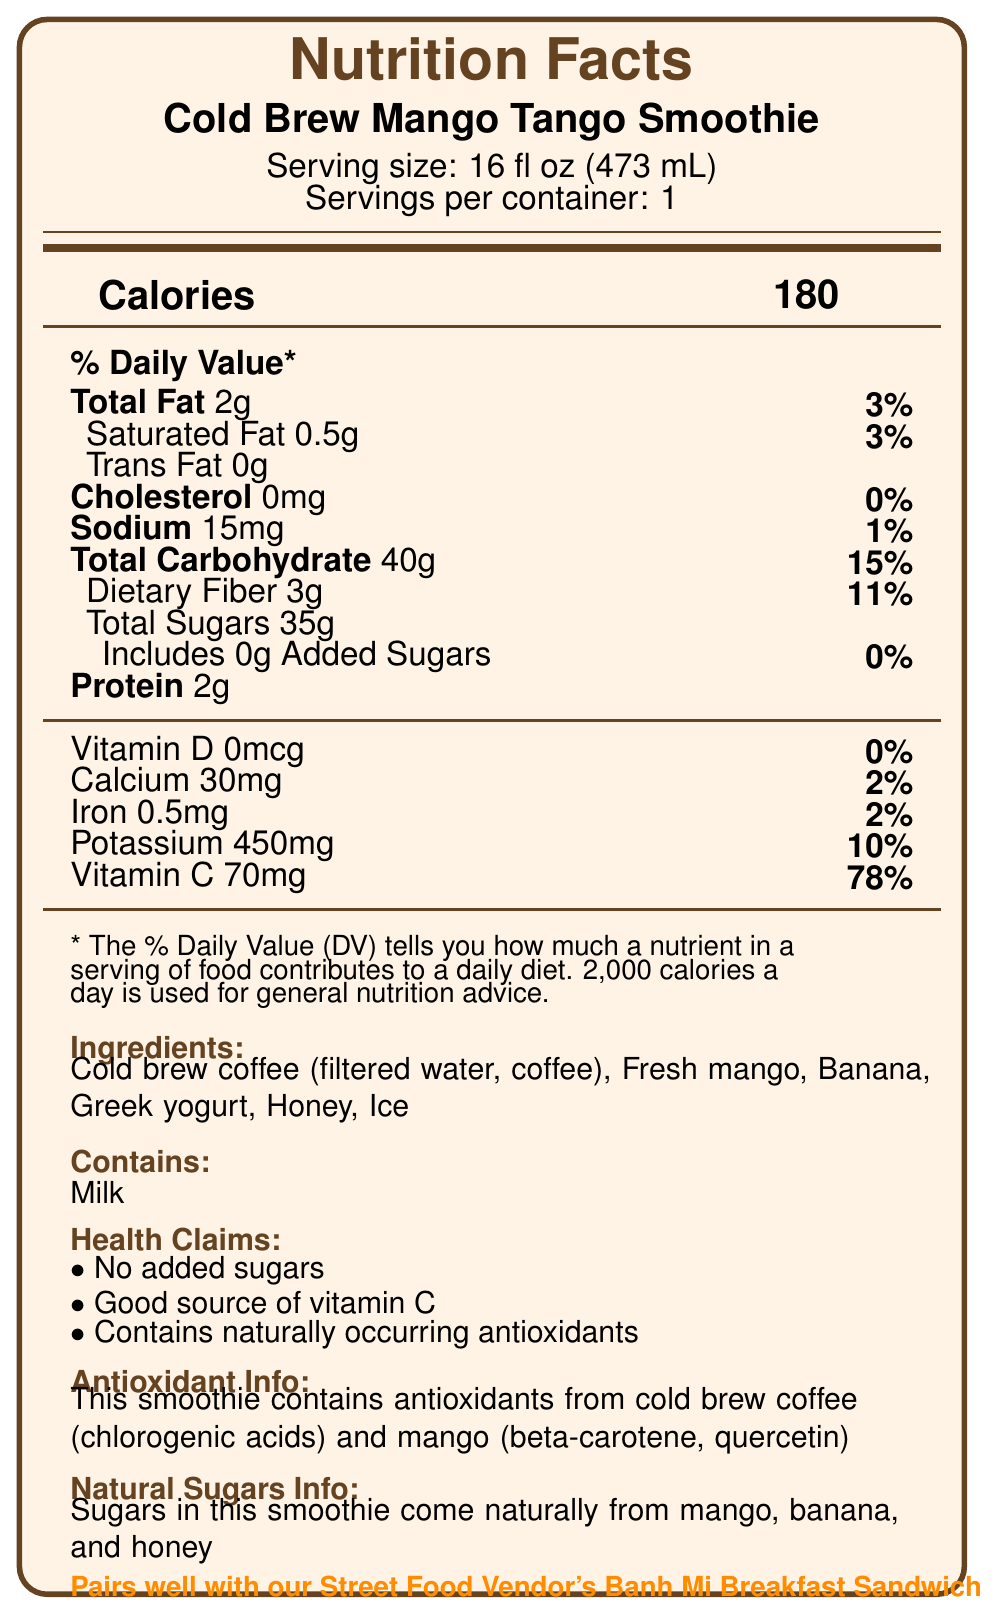what is the serving size of the Cold Brew Mango Tango Smoothie? The serving size is explicitly stated under the product name on the label.
Answer: 16 fl oz (473 mL) how many calories are in one serving of the Cold Brew Mango Tango Smoothie? The number of calories is prominently displayed in the middle of the Nutrition Facts section.
Answer: 180 calories what feature makes this product a good source of vitamin C? The vitamin C content and its percentage of the Daily Value are listed in the Nutrition Facts.
Answer: Contains 70mg of vitamin C per serving, 78% of the Daily Value what are the main sources of sugars in the Cold Brew Mango Tango Smoothie? The Natural Sugars Info section states that sugars come naturally from these ingredients.
Answer: Mango, banana, and honey how much protein does one serving provide? The amount of protein is listed in the Nutrition Facts under the "Protein" section.
Answer: 2g which of the following nutrients is NOT present in the Cold Brew Mango Tango Smoothie? A. Vitamin C B. Calcium C. Vitamin D Vitamin D is listed as 0mcg, which is 0% of the Daily Value.
Answer: C. Vitamin D what is the daily value percentage of dietary fiber in one serving? A. 5% B. 11% C. 15% D. 20% The percentage daily value of dietary fiber is listed as 11% in the Nutrition Facts.
Answer: B. 11% does the Cold Brew Mango Tango Smoothie contain any trans fats? The Nutrition Facts label specifies "Trans Fat 0g".
Answer: No does this product contain any added sugars? The Nutrition Facts state "Includes 0g Added Sugars" which means there are no added sugars.
Answer: No summarize the main features of the Cold Brew Mango Tango Smoothie based on the Nutrition Facts label. This summary includes details about serving size, calorie content, macronutrients, key vitamins, ingredients, pairing suggestions, and allergens.
Answer: The Cold Brew Mango Tango Smoothie is a 16 fl oz drink with 180 calories per serving. It contains 2g of total fat, 40g of carbohydrates, 35g of total sugars with no added sugars, and 2g of protein. It is rich in vitamin C, providing 78% of the daily value, and contains naturally occurring antioxidants from cold brew coffee and mango. It is recommended to pair with a Banh Mi Breakfast Sandwich. The ingredients include cold brew coffee, mango, banana, Greek yogurt, honey, and ice, and it contains milk. what is the main antioxidant source from coffee in the Cold Brew Mango Tango Smoothie? The Antioxidant Info section states that chlorogenic acids from the cold brew coffee are one of the smoothie’s antioxidant sources.
Answer: Chlorogenic acids how much potassium does one serving of this smoothie provide? The amount of potassium is listed in the Nutrition Facts, showing 450mg per serving.
Answer: 450mg is the Cold Brew Mango Tango Smoothie a good source of iron? While the smoothie contains 0.5mg of iron, this is only 2% of the daily value, which is not considered a good source.
Answer: No is the Cold Brew Mango Tango Smoothie environmentally friendly? The document notes that the smoothie uses locally sourced fruits and eco-friendly packaging.
Answer: Yes what is the daily value percentage of calcium in one serving? The percentage daily value of calcium is listed in the Nutrition Facts as 2%.
Answer: 2% what is the total amount of sugars per serving, including natural and added sugars? The total sugars per serving is listed as 35g and there are no added sugars, meaning all 35g are natural sugars.
Answer: 35g how often should one consume this smoothie to meet half their daily potassium needs? The document does not provide the daily potassium requirement, making it impossible to determine how often one should consume the smoothie to meet half of this need.
Answer: Cannot be determined 